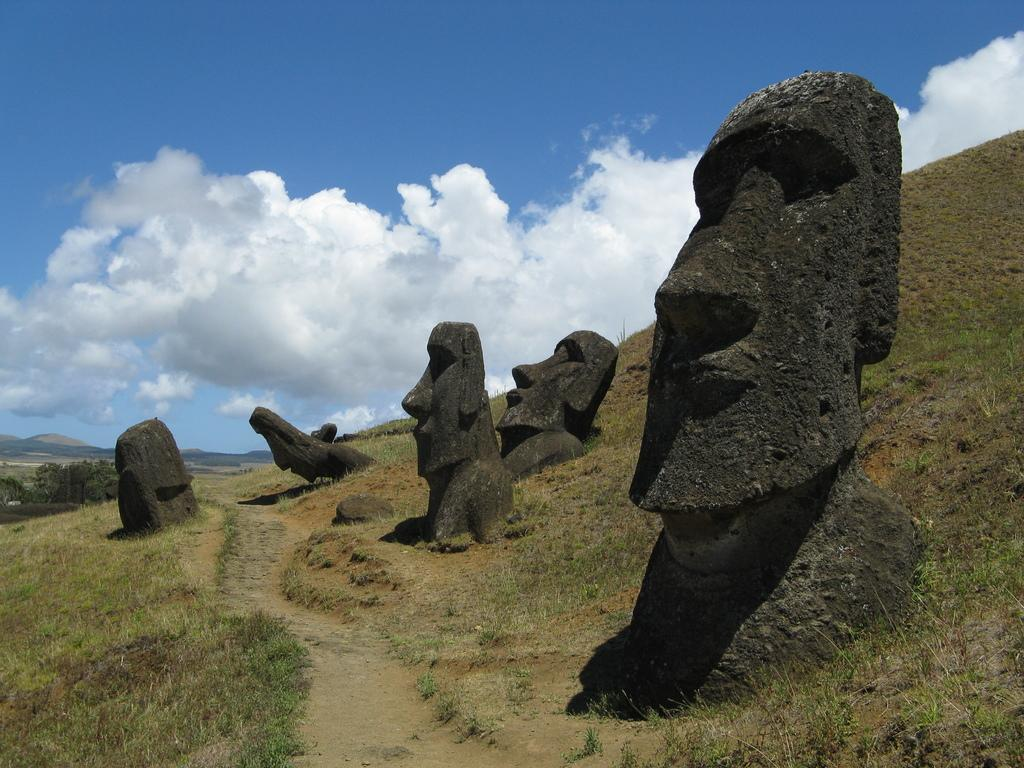What is located at the bottom side of the image? There is a path at the bottom side of the image. What can be seen in the center of the image? There are statues on the grassland in the center of the image. What type of vegetation is visible in the image? There are trees visible in the image. What is visible in the background of the image? There are mountains and the sky visible in the background of the image. How does the potato contribute to the fear in the image? There is no potato present in the image, and therefore no such contribution to fear can be observed. What nerve is responsible for the movement of the trees in the image? The trees in the image are stationary, and there is no indication of any movement or nerves involved. 